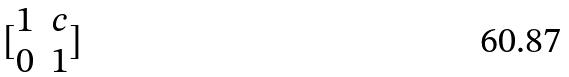<formula> <loc_0><loc_0><loc_500><loc_500>[ \begin{matrix} 1 & c \\ 0 & 1 \end{matrix} ]</formula> 